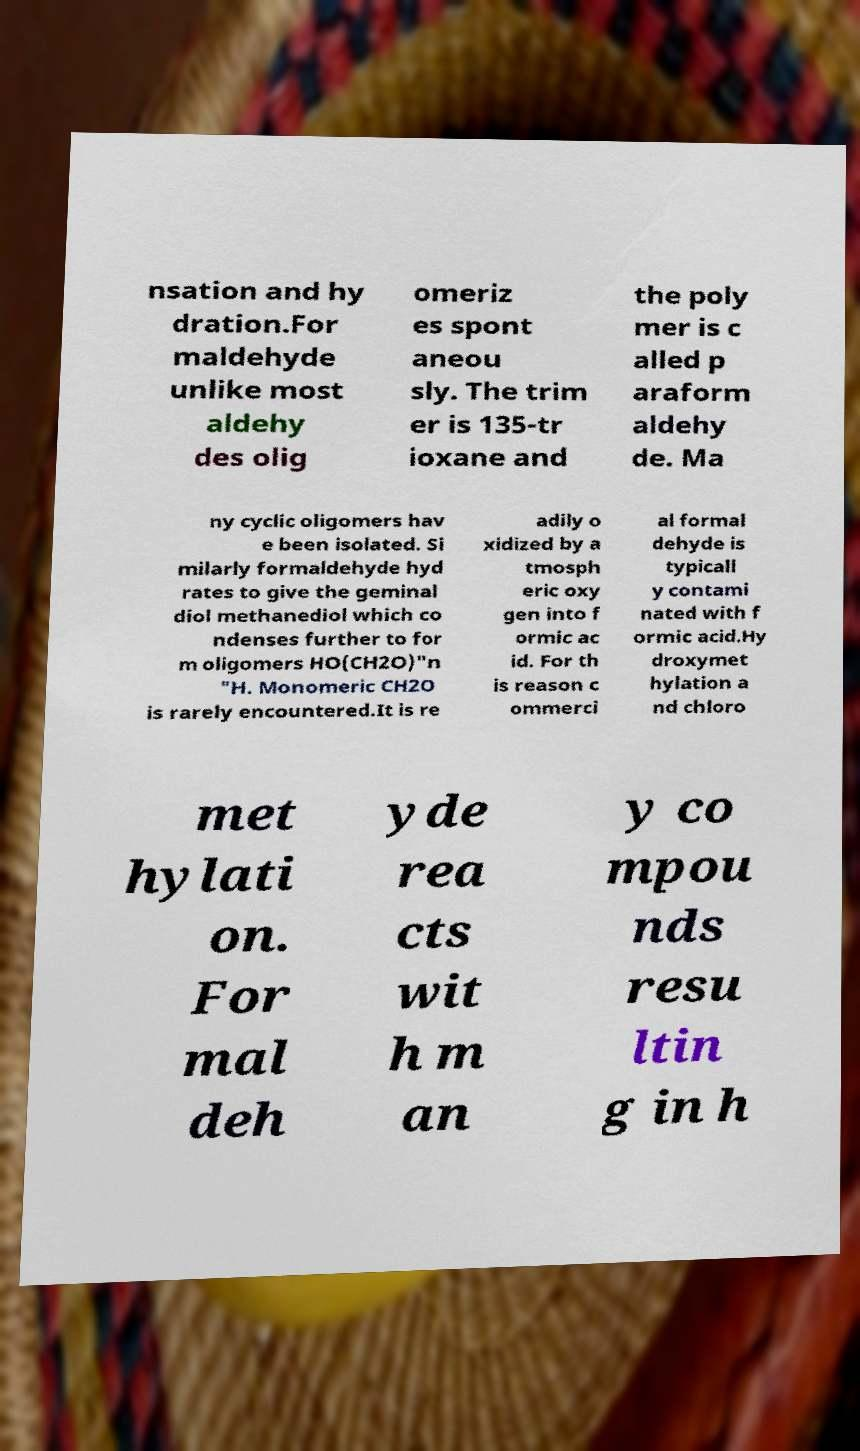Can you accurately transcribe the text from the provided image for me? nsation and hy dration.For maldehyde unlike most aldehy des olig omeriz es spont aneou sly. The trim er is 135-tr ioxane and the poly mer is c alled p araform aldehy de. Ma ny cyclic oligomers hav e been isolated. Si milarly formaldehyde hyd rates to give the geminal diol methanediol which co ndenses further to for m oligomers HO(CH2O)"n "H. Monomeric CH2O is rarely encountered.It is re adily o xidized by a tmosph eric oxy gen into f ormic ac id. For th is reason c ommerci al formal dehyde is typicall y contami nated with f ormic acid.Hy droxymet hylation a nd chloro met hylati on. For mal deh yde rea cts wit h m an y co mpou nds resu ltin g in h 